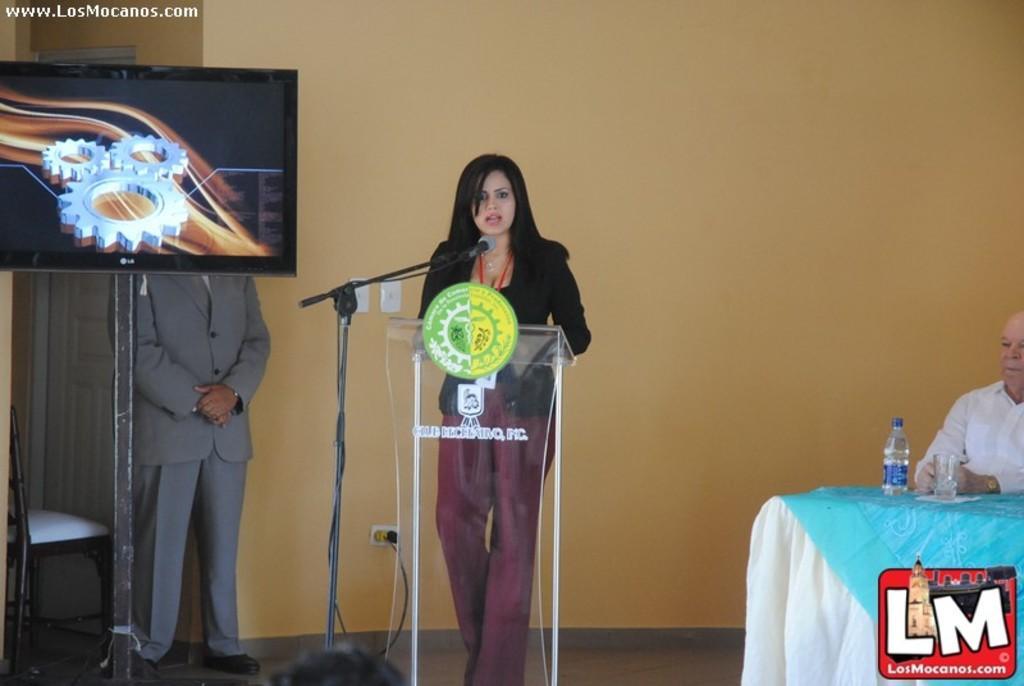How would you summarize this image in a sentence or two? In this image a lady is standing behind a podium. In front of her there is a mic. She is talking something. In the right an old man is sitting. In front of him on a table there is a bottle and a glass. Here another person is standing wearing grey suit. Here there is a screen. In the left there is a chair. 